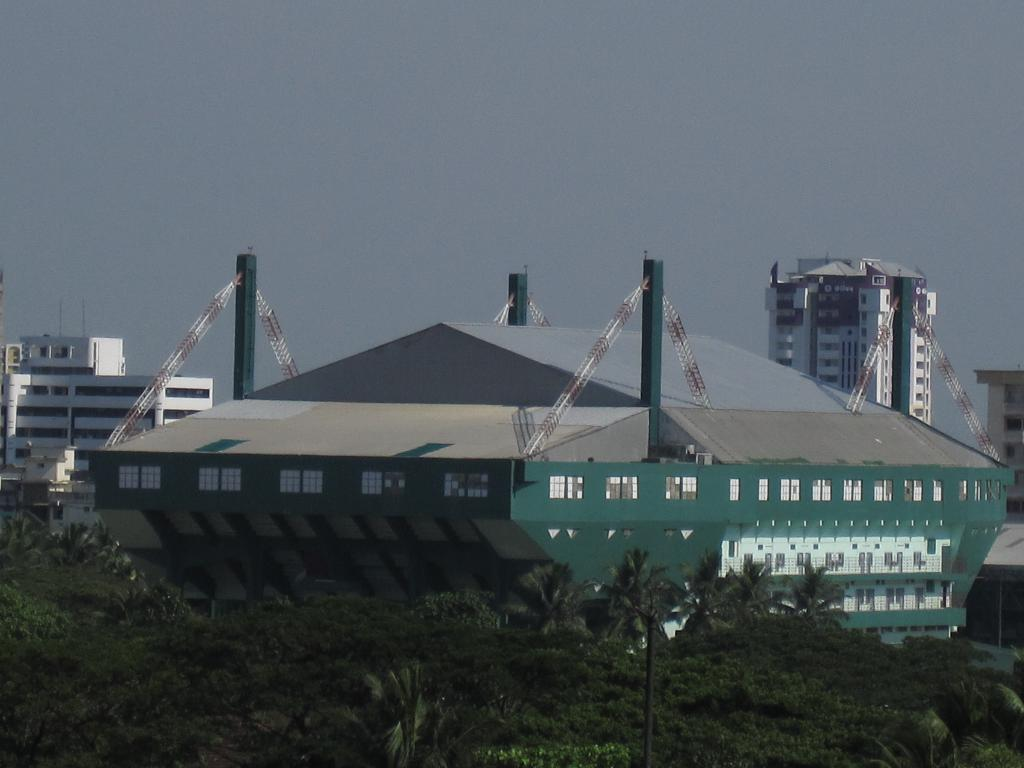What type of vegetation can be seen in the image? There are trees in the image. What structures are located behind the trees? There are buildings behind the trees. What is visible at the top of the image? The sky is visible at the top of the image. What object can be found at the bottom of the image? There is a pole at the bottom of the image. Can you read the letters on the doctor's coat in the image? There is no doctor or letters on a coat present in the image. How does the zipper on the doctor's bag work in the image? There is no doctor, bag, or zipper present in the image. 